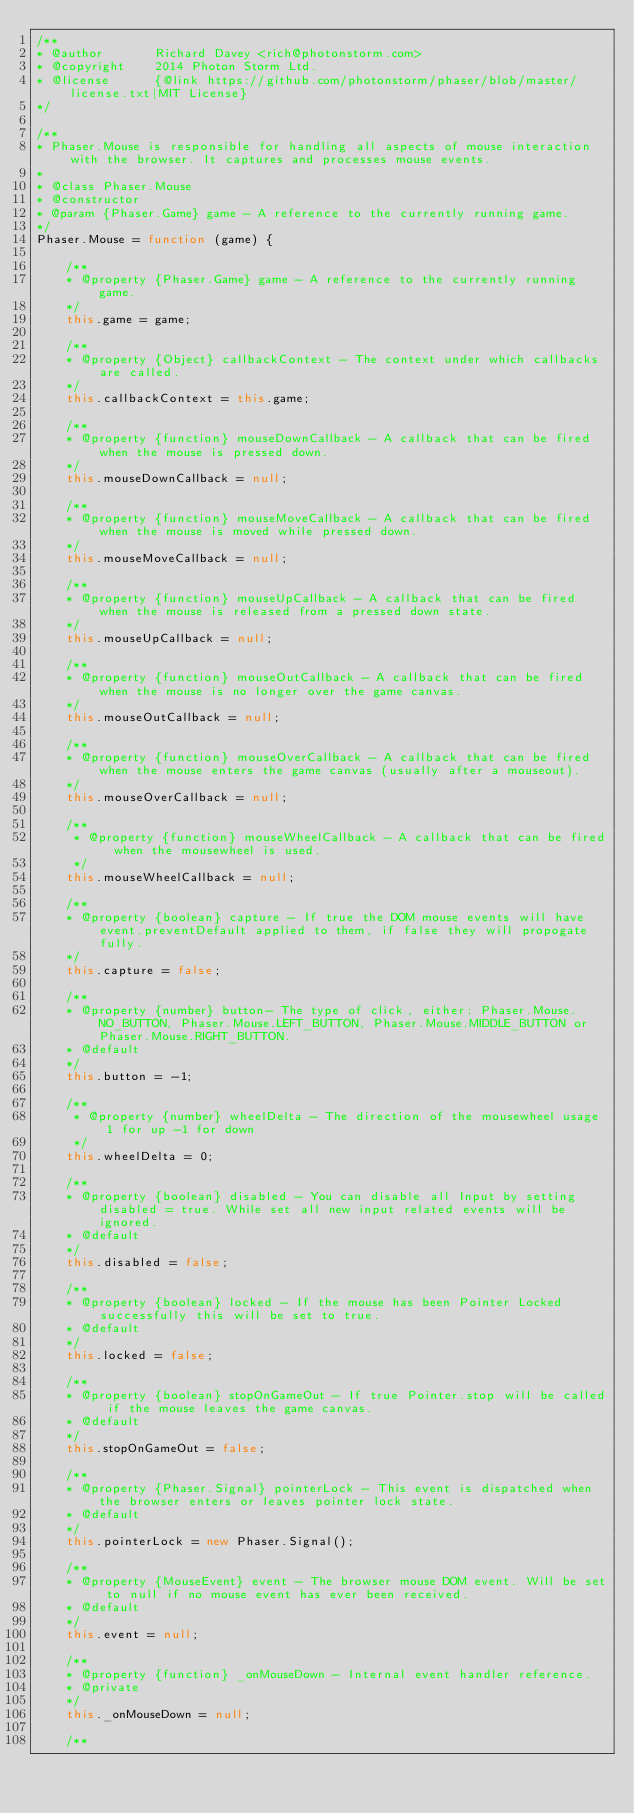Convert code to text. <code><loc_0><loc_0><loc_500><loc_500><_JavaScript_>/**
* @author       Richard Davey <rich@photonstorm.com>
* @copyright    2014 Photon Storm Ltd.
* @license      {@link https://github.com/photonstorm/phaser/blob/master/license.txt|MIT License}
*/

/**
* Phaser.Mouse is responsible for handling all aspects of mouse interaction with the browser. It captures and processes mouse events.
*
* @class Phaser.Mouse
* @constructor
* @param {Phaser.Game} game - A reference to the currently running game.
*/
Phaser.Mouse = function (game) {

    /**
    * @property {Phaser.Game} game - A reference to the currently running game.
    */
    this.game = game;

    /**
    * @property {Object} callbackContext - The context under which callbacks are called.
    */
    this.callbackContext = this.game;

    /**
    * @property {function} mouseDownCallback - A callback that can be fired when the mouse is pressed down.
    */
    this.mouseDownCallback = null;

    /**
    * @property {function} mouseMoveCallback - A callback that can be fired when the mouse is moved while pressed down.
    */
    this.mouseMoveCallback = null;

    /**
    * @property {function} mouseUpCallback - A callback that can be fired when the mouse is released from a pressed down state.
    */
    this.mouseUpCallback = null;

    /**
    * @property {function} mouseOutCallback - A callback that can be fired when the mouse is no longer over the game canvas.
    */
    this.mouseOutCallback = null;

    /**
    * @property {function} mouseOverCallback - A callback that can be fired when the mouse enters the game canvas (usually after a mouseout).
    */
    this.mouseOverCallback = null;

    /**
     * @property {function} mouseWheelCallback - A callback that can be fired when the mousewheel is used.
     */
    this.mouseWheelCallback = null;

    /**
    * @property {boolean} capture - If true the DOM mouse events will have event.preventDefault applied to them, if false they will propogate fully.
    */
    this.capture = false;

    /**
    * @property {number} button- The type of click, either: Phaser.Mouse.NO_BUTTON, Phaser.Mouse.LEFT_BUTTON, Phaser.Mouse.MIDDLE_BUTTON or Phaser.Mouse.RIGHT_BUTTON.
    * @default
    */
    this.button = -1;

    /**
     * @property {number} wheelDelta - The direction of the mousewheel usage 1 for up -1 for down
     */
    this.wheelDelta = 0;

    /**
    * @property {boolean} disabled - You can disable all Input by setting disabled = true. While set all new input related events will be ignored.
    * @default
    */
    this.disabled = false;

    /**
    * @property {boolean} locked - If the mouse has been Pointer Locked successfully this will be set to true.
    * @default
    */
    this.locked = false;

    /**
    * @property {boolean} stopOnGameOut - If true Pointer.stop will be called if the mouse leaves the game canvas.
    * @default
    */
    this.stopOnGameOut = false;

    /**
    * @property {Phaser.Signal} pointerLock - This event is dispatched when the browser enters or leaves pointer lock state.
    * @default
    */
    this.pointerLock = new Phaser.Signal();

    /**
    * @property {MouseEvent} event - The browser mouse DOM event. Will be set to null if no mouse event has ever been received.
    * @default
    */
    this.event = null;

    /**
    * @property {function} _onMouseDown - Internal event handler reference.
    * @private
    */
    this._onMouseDown = null;

    /**</code> 